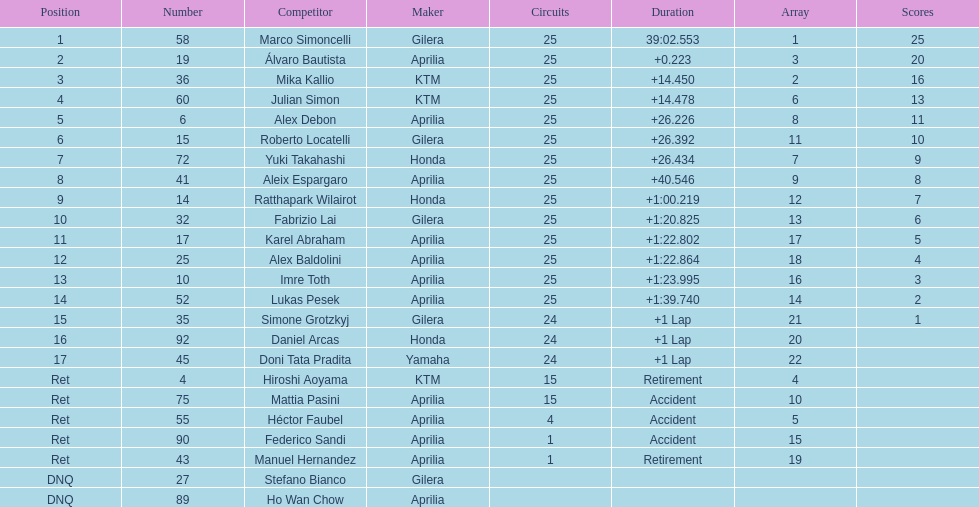The total amount of riders who did not qualify 2. Give me the full table as a dictionary. {'header': ['Position', 'Number', 'Competitor', 'Maker', 'Circuits', 'Duration', 'Array', 'Scores'], 'rows': [['1', '58', 'Marco Simoncelli', 'Gilera', '25', '39:02.553', '1', '25'], ['2', '19', 'Álvaro Bautista', 'Aprilia', '25', '+0.223', '3', '20'], ['3', '36', 'Mika Kallio', 'KTM', '25', '+14.450', '2', '16'], ['4', '60', 'Julian Simon', 'KTM', '25', '+14.478', '6', '13'], ['5', '6', 'Alex Debon', 'Aprilia', '25', '+26.226', '8', '11'], ['6', '15', 'Roberto Locatelli', 'Gilera', '25', '+26.392', '11', '10'], ['7', '72', 'Yuki Takahashi', 'Honda', '25', '+26.434', '7', '9'], ['8', '41', 'Aleix Espargaro', 'Aprilia', '25', '+40.546', '9', '8'], ['9', '14', 'Ratthapark Wilairot', 'Honda', '25', '+1:00.219', '12', '7'], ['10', '32', 'Fabrizio Lai', 'Gilera', '25', '+1:20.825', '13', '6'], ['11', '17', 'Karel Abraham', 'Aprilia', '25', '+1:22.802', '17', '5'], ['12', '25', 'Alex Baldolini', 'Aprilia', '25', '+1:22.864', '18', '4'], ['13', '10', 'Imre Toth', 'Aprilia', '25', '+1:23.995', '16', '3'], ['14', '52', 'Lukas Pesek', 'Aprilia', '25', '+1:39.740', '14', '2'], ['15', '35', 'Simone Grotzkyj', 'Gilera', '24', '+1 Lap', '21', '1'], ['16', '92', 'Daniel Arcas', 'Honda', '24', '+1 Lap', '20', ''], ['17', '45', 'Doni Tata Pradita', 'Yamaha', '24', '+1 Lap', '22', ''], ['Ret', '4', 'Hiroshi Aoyama', 'KTM', '15', 'Retirement', '4', ''], ['Ret', '75', 'Mattia Pasini', 'Aprilia', '15', 'Accident', '10', ''], ['Ret', '55', 'Héctor Faubel', 'Aprilia', '4', 'Accident', '5', ''], ['Ret', '90', 'Federico Sandi', 'Aprilia', '1', 'Accident', '15', ''], ['Ret', '43', 'Manuel Hernandez', 'Aprilia', '1', 'Retirement', '19', ''], ['DNQ', '27', 'Stefano Bianco', 'Gilera', '', '', '', ''], ['DNQ', '89', 'Ho Wan Chow', 'Aprilia', '', '', '', '']]} 